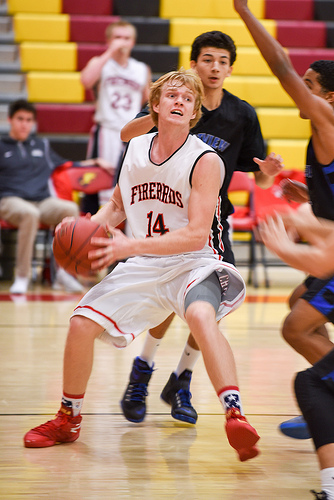<image>
Can you confirm if the man is on the ball? No. The man is not positioned on the ball. They may be near each other, but the man is not supported by or resting on top of the ball. Is there a defender in front of the ball handler? No. The defender is not in front of the ball handler. The spatial positioning shows a different relationship between these objects. 